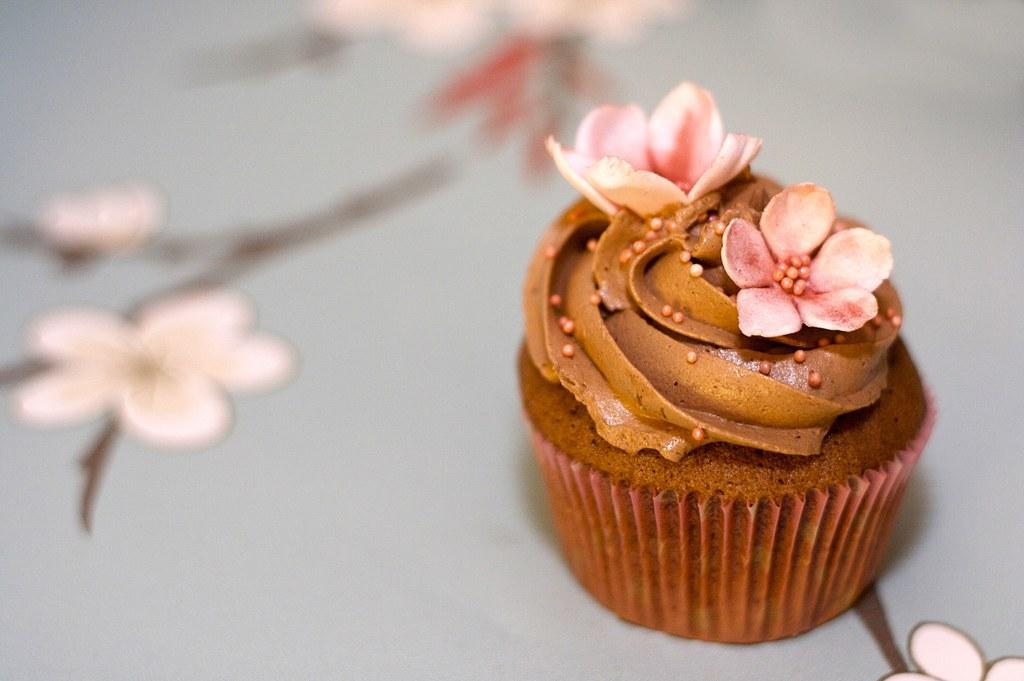What type of dessert can be seen in the image? There is a cupcake in the image. How is the cupcake decorated? The cupcake is garnished with flowers. Where is the cupcake located? The cupcake is placed on a table. What is the design on the table? The table has floral designs. What type of vessel is used to transport the zephyr in the image? There is no mention of a vessel or zephyr in the image; it features a cupcake with floral garnish on a table with floral designs. 